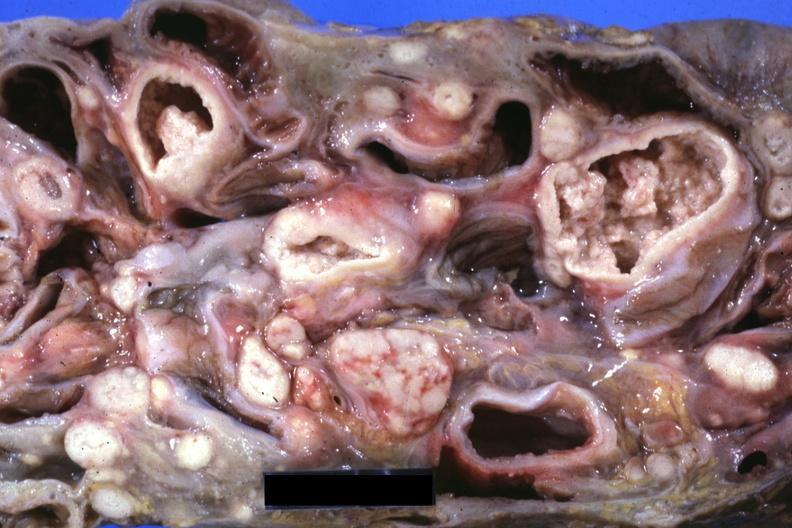s lymph node present?
Answer the question using a single word or phrase. Yes 